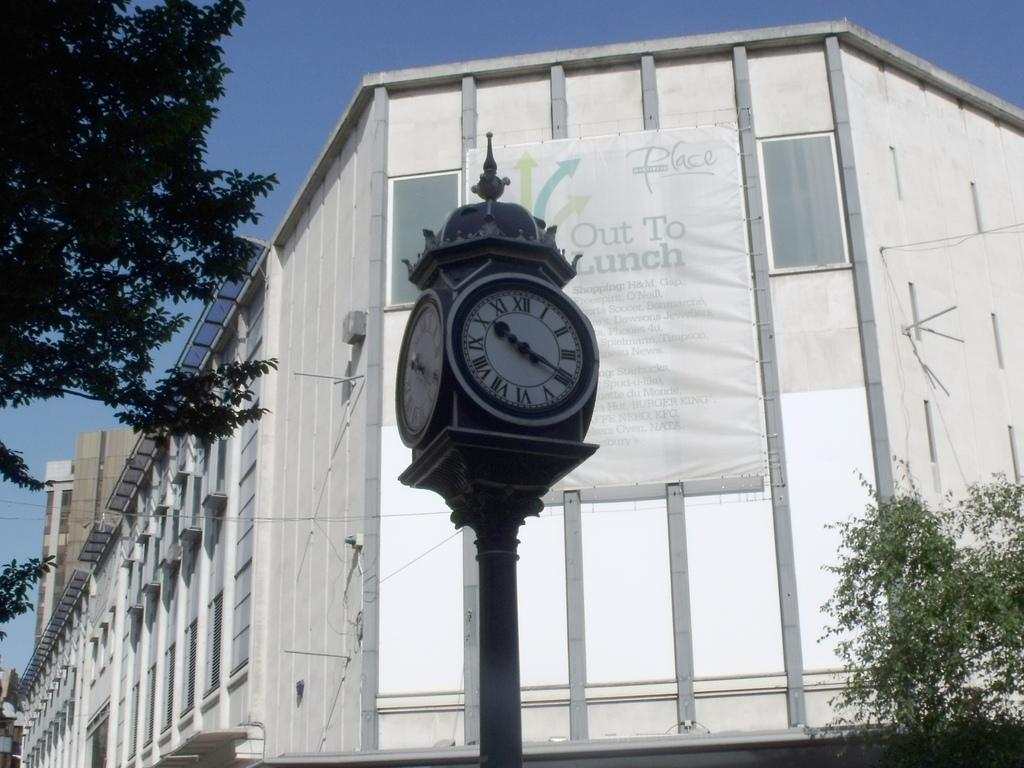<image>
Present a compact description of the photo's key features. A sign on a white building says "Out To Lunch". 